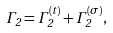Convert formula to latex. <formula><loc_0><loc_0><loc_500><loc_500>\Gamma _ { 2 } = \Gamma ^ { ( t ) } _ { 2 } + \Gamma ^ { ( \sigma ) } _ { 2 } ,</formula> 